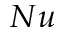Convert formula to latex. <formula><loc_0><loc_0><loc_500><loc_500>N u</formula> 